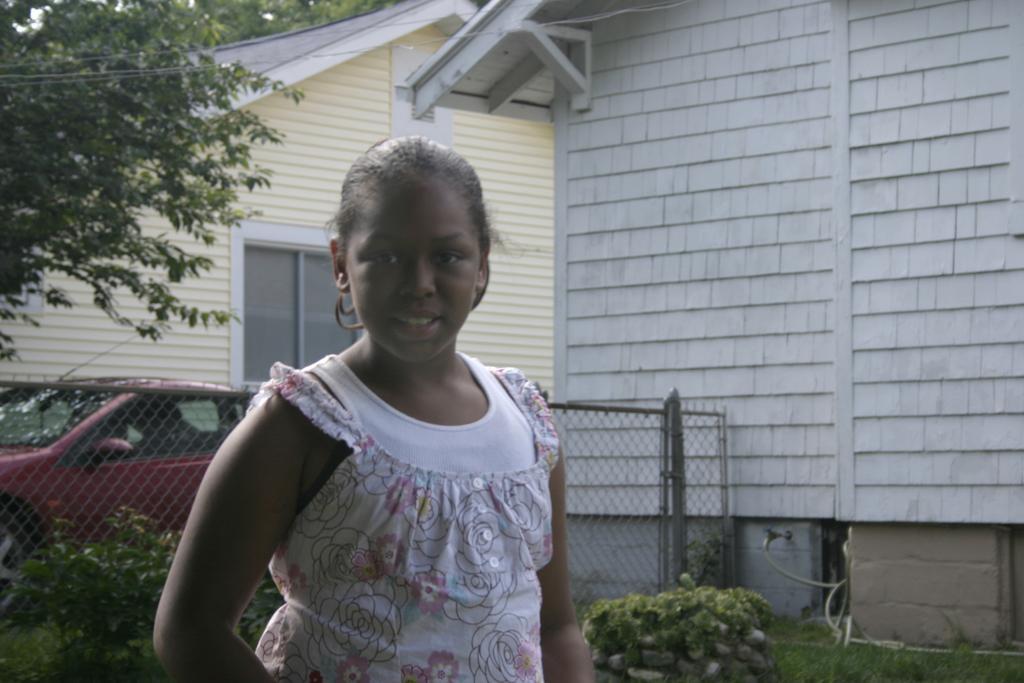Describe this image in one or two sentences. In this image we can see a woman wearing a dress is stunning. On the left side of the image we can see a fence, car placed on the ground, group of plants. In the background, we can see two buildings with roof and a window and a group of trees. 